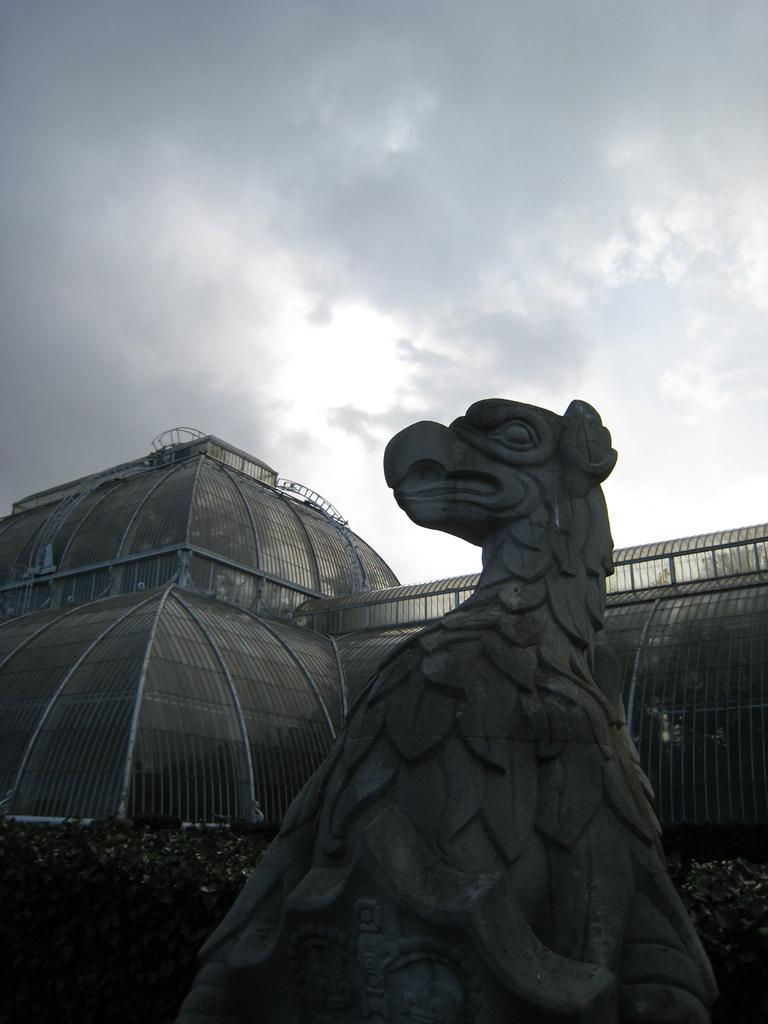What can be seen in the background of the image? The sky is visible in the image. What type of structure is present in the image? There is a building in the image, but it is truncated. What type of vegetation is present in the image? There are plants in the image. What type of artwork is present in the image? There is a sculpture in the image, but it is truncated towards the bottom of the image. How many doors can be seen on the building in the image? There is no door visible in the image, as the building is truncated. What type of unit is used to measure the height of the sculpture in the image? There is no information provided about the height of the sculpture or the unit of measurement used, so it cannot be determined from the image. 